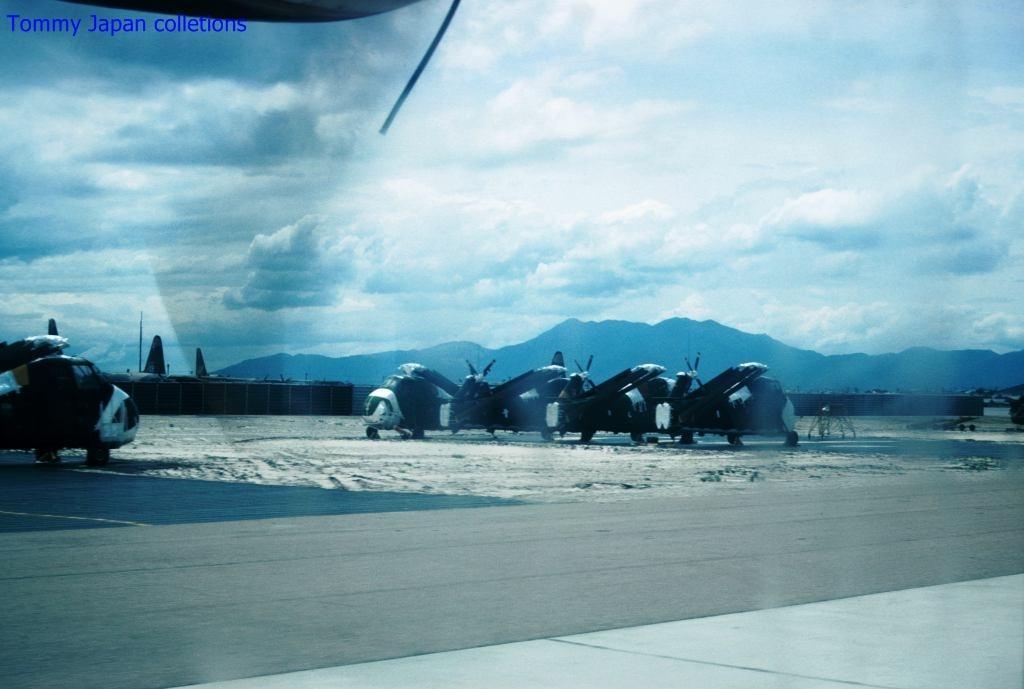Please provide a concise description of this image. In this picture we can observe some airplanes on the runway. In the background we can observe hills. There is a sky with number of clouds. On the left side we can observe blue color words in this picture. 